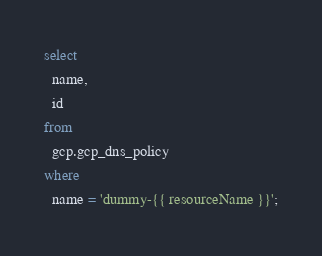Convert code to text. <code><loc_0><loc_0><loc_500><loc_500><_SQL_>select
  name,
  id
from
  gcp.gcp_dns_policy
where
  name = 'dummy-{{ resourceName }}';</code> 